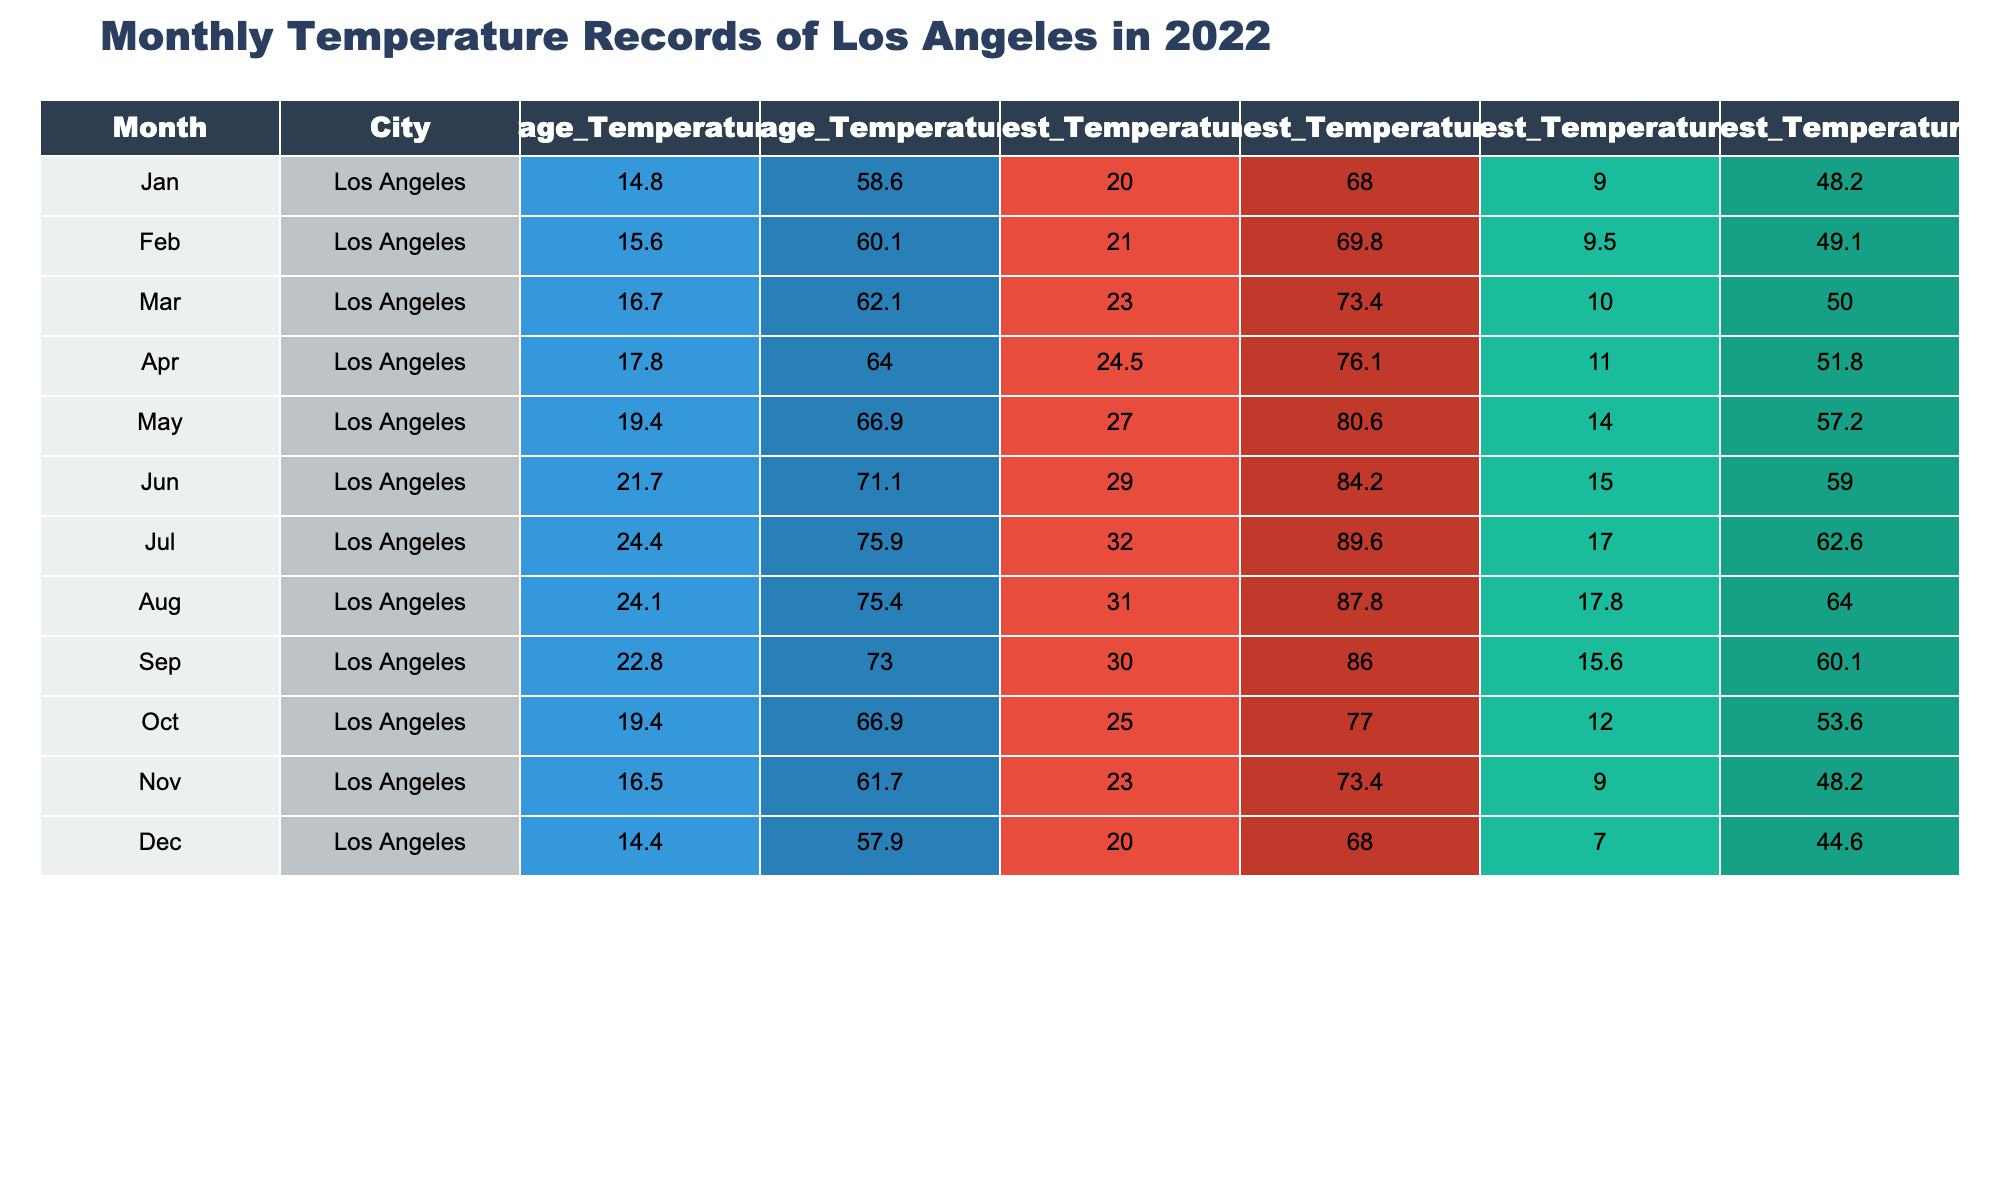What is the average temperature in Los Angeles for July? The table shows the average temperature for July is 24.4 °C. This value is directly retrieved from the corresponding row for July in the Average_Temperature_°C column.
Answer: 24.4 °C What was the highest temperature recorded in Los Angeles in April? Looking at the row for April in the Highest_Temperature_°C column, we find the highest temperature was 24.5 °C. This is a straightforward retrieval from the table.
Answer: 24.5 °C Which month had the lowest average temperature in Los Angeles? By comparing the values in the Average_Temperature_°C column, January has the lowest average temperature at 14.8 °C; thus, January is the answer.
Answer: January Calculate the difference between the highest and lowest temperatures in December. For December, the highest temperature is 20.0 °C and the lowest is 7.0 °C. The difference is calculated as 20.0 °C - 7.0 °C = 13.0 °C.
Answer: 13.0 °C Was the average temperature in September higher or lower than 22 °C? The average temperature in September is 22.8 °C, which is higher than 22 °C. This is a straightforward comparison based on the Average_Temperature_°C column for September.
Answer: Higher What was the average temperature of the first half of the year (January to June)? For the first half of the year, the average temperatures are: January (14.8 °C), February (15.6 °C), March (16.7 °C), April (17.8 °C), May (19.4 °C), and June (21.7 °C). First, sum these values: 14.8 + 15.6 + 16.7 + 17.8 + 19.4 + 21.7 = 105.0 °C. Then, divide by 6 to get the average: 105.0 °C / 6 = 17.5 °C.
Answer: 17.5 °C Which month had the largest temperature range (difference between highest and lowest temperatures)? To determine this, we calculate the temperature range for each month by subtracting the lowest temperature from the highest temperature. For example, in January, the range is 20.0 °C - 9.0 °C = 11.0 °C. After performing this for all months, we find that July has the largest range: 32.0 °C - 17.0 °C = 15.0 °C. Therefore, July had the largest temperature range.
Answer: July Is it true that November had an average temperature above 15 °C? The Average_Temperature_°C for November is 16.5 °C, which is above 15 °C; hence the statement is true. This is verified by checking the Average_Temperature_°C column for November.
Answer: True What is the average monthly temperature in Los Angeles for the whole year? To calculate the average, we sum all the average temperatures from each month: 14.8 + 15.6 + 16.7 + 17.8 + 19.4 + 21.7 + 24.4 + 24.1 + 22.8 + 19.4 + 16.5 + 14.4 =  19.0 °C. Then, divide by 12 months:  19.0 °C / 12 = 19.0 °C. Therefore, the average monthly temperature in Los Angeles for the year is computed as 19.0 °C.
Answer: 19.0 °C 